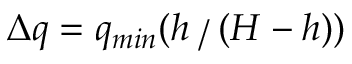Convert formula to latex. <formula><loc_0><loc_0><loc_500><loc_500>\Delta q = q _ { \min } ( h ( H - h ) )</formula> 